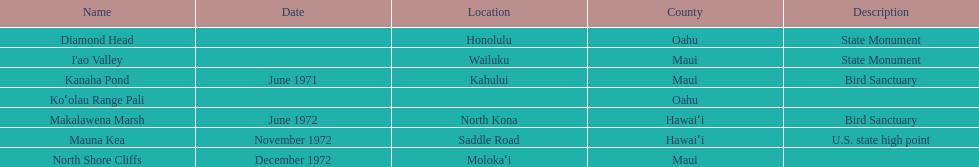Which county is featured the most on the chart? Maui. 